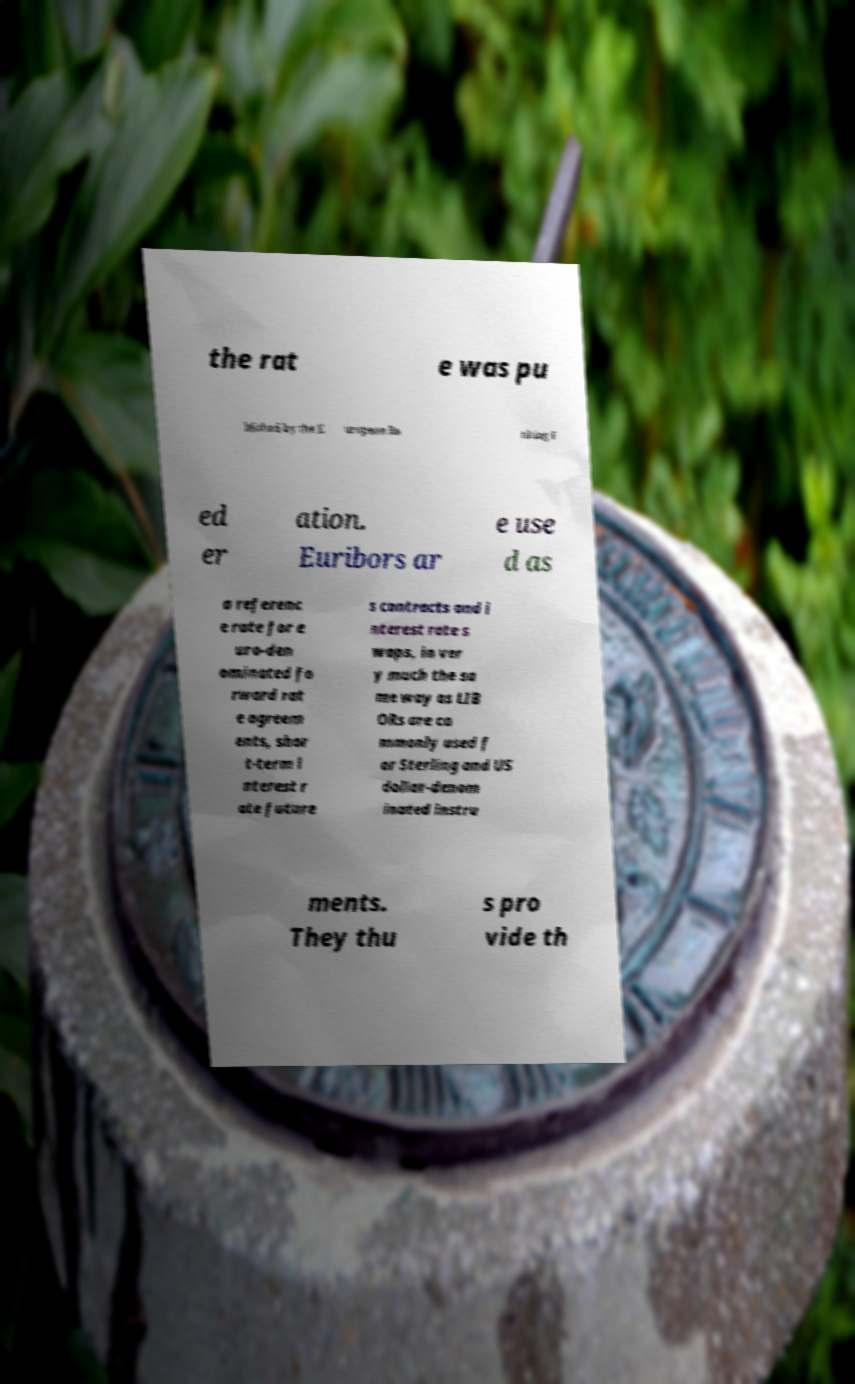Please read and relay the text visible in this image. What does it say? the rat e was pu blished by the E uropean Ba nking F ed er ation. Euribors ar e use d as a referenc e rate for e uro-den ominated fo rward rat e agreem ents, shor t-term i nterest r ate future s contracts and i nterest rate s waps, in ver y much the sa me way as LIB ORs are co mmonly used f or Sterling and US dollar-denom inated instru ments. They thu s pro vide th 